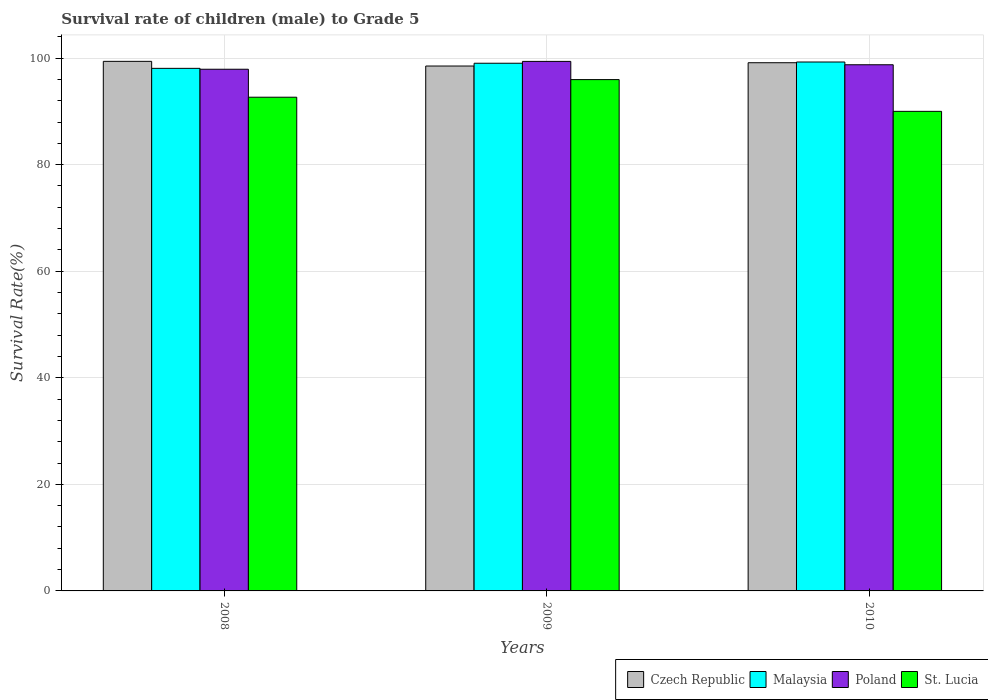How many different coloured bars are there?
Provide a short and direct response. 4. How many groups of bars are there?
Provide a short and direct response. 3. Are the number of bars per tick equal to the number of legend labels?
Your response must be concise. Yes. What is the survival rate of male children to grade 5 in Czech Republic in 2010?
Make the answer very short. 99.13. Across all years, what is the maximum survival rate of male children to grade 5 in Malaysia?
Your response must be concise. 99.26. Across all years, what is the minimum survival rate of male children to grade 5 in Czech Republic?
Ensure brevity in your answer.  98.51. In which year was the survival rate of male children to grade 5 in St. Lucia minimum?
Your answer should be compact. 2010. What is the total survival rate of male children to grade 5 in St. Lucia in the graph?
Make the answer very short. 278.62. What is the difference between the survival rate of male children to grade 5 in Czech Republic in 2008 and that in 2010?
Your response must be concise. 0.26. What is the difference between the survival rate of male children to grade 5 in Poland in 2008 and the survival rate of male children to grade 5 in Malaysia in 2010?
Provide a short and direct response. -1.36. What is the average survival rate of male children to grade 5 in Poland per year?
Your response must be concise. 98.67. In the year 2009, what is the difference between the survival rate of male children to grade 5 in Czech Republic and survival rate of male children to grade 5 in Malaysia?
Make the answer very short. -0.52. In how many years, is the survival rate of male children to grade 5 in Czech Republic greater than 64 %?
Your response must be concise. 3. What is the ratio of the survival rate of male children to grade 5 in Czech Republic in 2008 to that in 2009?
Keep it short and to the point. 1.01. Is the difference between the survival rate of male children to grade 5 in Czech Republic in 2008 and 2009 greater than the difference between the survival rate of male children to grade 5 in Malaysia in 2008 and 2009?
Your answer should be compact. Yes. What is the difference between the highest and the second highest survival rate of male children to grade 5 in Malaysia?
Keep it short and to the point. 0.23. What is the difference between the highest and the lowest survival rate of male children to grade 5 in Poland?
Ensure brevity in your answer.  1.47. In how many years, is the survival rate of male children to grade 5 in St. Lucia greater than the average survival rate of male children to grade 5 in St. Lucia taken over all years?
Your answer should be compact. 1. What does the 2nd bar from the left in 2010 represents?
Give a very brief answer. Malaysia. What does the 2nd bar from the right in 2010 represents?
Your response must be concise. Poland. How many bars are there?
Your answer should be compact. 12. How many years are there in the graph?
Ensure brevity in your answer.  3. Does the graph contain any zero values?
Your response must be concise. No. Where does the legend appear in the graph?
Your answer should be very brief. Bottom right. How are the legend labels stacked?
Make the answer very short. Horizontal. What is the title of the graph?
Give a very brief answer. Survival rate of children (male) to Grade 5. What is the label or title of the X-axis?
Your response must be concise. Years. What is the label or title of the Y-axis?
Provide a short and direct response. Survival Rate(%). What is the Survival Rate(%) in Czech Republic in 2008?
Make the answer very short. 99.38. What is the Survival Rate(%) of Malaysia in 2008?
Make the answer very short. 98.07. What is the Survival Rate(%) in Poland in 2008?
Offer a terse response. 97.9. What is the Survival Rate(%) of St. Lucia in 2008?
Your answer should be compact. 92.65. What is the Survival Rate(%) in Czech Republic in 2009?
Provide a short and direct response. 98.51. What is the Survival Rate(%) in Malaysia in 2009?
Offer a very short reply. 99.03. What is the Survival Rate(%) of Poland in 2009?
Provide a succinct answer. 99.38. What is the Survival Rate(%) in St. Lucia in 2009?
Keep it short and to the point. 95.96. What is the Survival Rate(%) of Czech Republic in 2010?
Offer a very short reply. 99.13. What is the Survival Rate(%) of Malaysia in 2010?
Offer a very short reply. 99.26. What is the Survival Rate(%) of Poland in 2010?
Give a very brief answer. 98.74. What is the Survival Rate(%) in St. Lucia in 2010?
Ensure brevity in your answer.  90. Across all years, what is the maximum Survival Rate(%) in Czech Republic?
Your answer should be compact. 99.38. Across all years, what is the maximum Survival Rate(%) of Malaysia?
Offer a very short reply. 99.26. Across all years, what is the maximum Survival Rate(%) of Poland?
Your answer should be very brief. 99.38. Across all years, what is the maximum Survival Rate(%) of St. Lucia?
Your response must be concise. 95.96. Across all years, what is the minimum Survival Rate(%) of Czech Republic?
Offer a very short reply. 98.51. Across all years, what is the minimum Survival Rate(%) of Malaysia?
Ensure brevity in your answer.  98.07. Across all years, what is the minimum Survival Rate(%) of Poland?
Make the answer very short. 97.9. Across all years, what is the minimum Survival Rate(%) in St. Lucia?
Give a very brief answer. 90. What is the total Survival Rate(%) of Czech Republic in the graph?
Give a very brief answer. 297.02. What is the total Survival Rate(%) of Malaysia in the graph?
Provide a short and direct response. 296.36. What is the total Survival Rate(%) in Poland in the graph?
Make the answer very short. 296.02. What is the total Survival Rate(%) in St. Lucia in the graph?
Keep it short and to the point. 278.62. What is the difference between the Survival Rate(%) in Czech Republic in 2008 and that in 2009?
Provide a succinct answer. 0.88. What is the difference between the Survival Rate(%) of Malaysia in 2008 and that in 2009?
Offer a very short reply. -0.96. What is the difference between the Survival Rate(%) of Poland in 2008 and that in 2009?
Your answer should be very brief. -1.47. What is the difference between the Survival Rate(%) in St. Lucia in 2008 and that in 2009?
Make the answer very short. -3.31. What is the difference between the Survival Rate(%) in Czech Republic in 2008 and that in 2010?
Keep it short and to the point. 0.26. What is the difference between the Survival Rate(%) of Malaysia in 2008 and that in 2010?
Offer a terse response. -1.19. What is the difference between the Survival Rate(%) of Poland in 2008 and that in 2010?
Make the answer very short. -0.84. What is the difference between the Survival Rate(%) of St. Lucia in 2008 and that in 2010?
Your answer should be compact. 2.65. What is the difference between the Survival Rate(%) of Czech Republic in 2009 and that in 2010?
Your answer should be very brief. -0.62. What is the difference between the Survival Rate(%) in Malaysia in 2009 and that in 2010?
Offer a terse response. -0.23. What is the difference between the Survival Rate(%) in Poland in 2009 and that in 2010?
Your answer should be compact. 0.63. What is the difference between the Survival Rate(%) in St. Lucia in 2009 and that in 2010?
Make the answer very short. 5.96. What is the difference between the Survival Rate(%) of Czech Republic in 2008 and the Survival Rate(%) of Malaysia in 2009?
Give a very brief answer. 0.36. What is the difference between the Survival Rate(%) in Czech Republic in 2008 and the Survival Rate(%) in Poland in 2009?
Ensure brevity in your answer.  0.01. What is the difference between the Survival Rate(%) in Czech Republic in 2008 and the Survival Rate(%) in St. Lucia in 2009?
Your answer should be very brief. 3.42. What is the difference between the Survival Rate(%) of Malaysia in 2008 and the Survival Rate(%) of Poland in 2009?
Keep it short and to the point. -1.31. What is the difference between the Survival Rate(%) in Malaysia in 2008 and the Survival Rate(%) in St. Lucia in 2009?
Your answer should be very brief. 2.11. What is the difference between the Survival Rate(%) in Poland in 2008 and the Survival Rate(%) in St. Lucia in 2009?
Provide a succinct answer. 1.94. What is the difference between the Survival Rate(%) of Czech Republic in 2008 and the Survival Rate(%) of Malaysia in 2010?
Keep it short and to the point. 0.12. What is the difference between the Survival Rate(%) of Czech Republic in 2008 and the Survival Rate(%) of Poland in 2010?
Offer a terse response. 0.64. What is the difference between the Survival Rate(%) in Czech Republic in 2008 and the Survival Rate(%) in St. Lucia in 2010?
Offer a very short reply. 9.38. What is the difference between the Survival Rate(%) of Malaysia in 2008 and the Survival Rate(%) of Poland in 2010?
Make the answer very short. -0.67. What is the difference between the Survival Rate(%) of Malaysia in 2008 and the Survival Rate(%) of St. Lucia in 2010?
Provide a short and direct response. 8.07. What is the difference between the Survival Rate(%) in Poland in 2008 and the Survival Rate(%) in St. Lucia in 2010?
Ensure brevity in your answer.  7.9. What is the difference between the Survival Rate(%) in Czech Republic in 2009 and the Survival Rate(%) in Malaysia in 2010?
Your answer should be compact. -0.75. What is the difference between the Survival Rate(%) of Czech Republic in 2009 and the Survival Rate(%) of Poland in 2010?
Make the answer very short. -0.24. What is the difference between the Survival Rate(%) in Czech Republic in 2009 and the Survival Rate(%) in St. Lucia in 2010?
Your answer should be compact. 8.51. What is the difference between the Survival Rate(%) of Malaysia in 2009 and the Survival Rate(%) of Poland in 2010?
Offer a terse response. 0.28. What is the difference between the Survival Rate(%) in Malaysia in 2009 and the Survival Rate(%) in St. Lucia in 2010?
Offer a terse response. 9.03. What is the difference between the Survival Rate(%) in Poland in 2009 and the Survival Rate(%) in St. Lucia in 2010?
Your answer should be compact. 9.38. What is the average Survival Rate(%) of Czech Republic per year?
Your answer should be very brief. 99.01. What is the average Survival Rate(%) in Malaysia per year?
Offer a very short reply. 98.79. What is the average Survival Rate(%) of Poland per year?
Ensure brevity in your answer.  98.67. What is the average Survival Rate(%) in St. Lucia per year?
Keep it short and to the point. 92.87. In the year 2008, what is the difference between the Survival Rate(%) in Czech Republic and Survival Rate(%) in Malaysia?
Offer a very short reply. 1.31. In the year 2008, what is the difference between the Survival Rate(%) in Czech Republic and Survival Rate(%) in Poland?
Offer a very short reply. 1.48. In the year 2008, what is the difference between the Survival Rate(%) in Czech Republic and Survival Rate(%) in St. Lucia?
Your answer should be compact. 6.73. In the year 2008, what is the difference between the Survival Rate(%) in Malaysia and Survival Rate(%) in Poland?
Offer a very short reply. 0.17. In the year 2008, what is the difference between the Survival Rate(%) of Malaysia and Survival Rate(%) of St. Lucia?
Ensure brevity in your answer.  5.42. In the year 2008, what is the difference between the Survival Rate(%) of Poland and Survival Rate(%) of St. Lucia?
Offer a terse response. 5.25. In the year 2009, what is the difference between the Survival Rate(%) in Czech Republic and Survival Rate(%) in Malaysia?
Your answer should be compact. -0.52. In the year 2009, what is the difference between the Survival Rate(%) of Czech Republic and Survival Rate(%) of Poland?
Offer a terse response. -0.87. In the year 2009, what is the difference between the Survival Rate(%) of Czech Republic and Survival Rate(%) of St. Lucia?
Offer a very short reply. 2.55. In the year 2009, what is the difference between the Survival Rate(%) in Malaysia and Survival Rate(%) in Poland?
Provide a succinct answer. -0.35. In the year 2009, what is the difference between the Survival Rate(%) of Malaysia and Survival Rate(%) of St. Lucia?
Give a very brief answer. 3.07. In the year 2009, what is the difference between the Survival Rate(%) in Poland and Survival Rate(%) in St. Lucia?
Provide a short and direct response. 3.42. In the year 2010, what is the difference between the Survival Rate(%) of Czech Republic and Survival Rate(%) of Malaysia?
Offer a very short reply. -0.14. In the year 2010, what is the difference between the Survival Rate(%) of Czech Republic and Survival Rate(%) of Poland?
Your answer should be very brief. 0.38. In the year 2010, what is the difference between the Survival Rate(%) of Czech Republic and Survival Rate(%) of St. Lucia?
Your response must be concise. 9.12. In the year 2010, what is the difference between the Survival Rate(%) of Malaysia and Survival Rate(%) of Poland?
Provide a short and direct response. 0.52. In the year 2010, what is the difference between the Survival Rate(%) of Malaysia and Survival Rate(%) of St. Lucia?
Provide a succinct answer. 9.26. In the year 2010, what is the difference between the Survival Rate(%) in Poland and Survival Rate(%) in St. Lucia?
Provide a succinct answer. 8.74. What is the ratio of the Survival Rate(%) of Czech Republic in 2008 to that in 2009?
Provide a short and direct response. 1.01. What is the ratio of the Survival Rate(%) in Malaysia in 2008 to that in 2009?
Make the answer very short. 0.99. What is the ratio of the Survival Rate(%) in Poland in 2008 to that in 2009?
Give a very brief answer. 0.99. What is the ratio of the Survival Rate(%) in St. Lucia in 2008 to that in 2009?
Provide a short and direct response. 0.97. What is the ratio of the Survival Rate(%) of Malaysia in 2008 to that in 2010?
Give a very brief answer. 0.99. What is the ratio of the Survival Rate(%) of Poland in 2008 to that in 2010?
Keep it short and to the point. 0.99. What is the ratio of the Survival Rate(%) of St. Lucia in 2008 to that in 2010?
Your answer should be compact. 1.03. What is the ratio of the Survival Rate(%) of Malaysia in 2009 to that in 2010?
Your answer should be compact. 1. What is the ratio of the Survival Rate(%) of Poland in 2009 to that in 2010?
Make the answer very short. 1.01. What is the ratio of the Survival Rate(%) in St. Lucia in 2009 to that in 2010?
Make the answer very short. 1.07. What is the difference between the highest and the second highest Survival Rate(%) in Czech Republic?
Provide a short and direct response. 0.26. What is the difference between the highest and the second highest Survival Rate(%) in Malaysia?
Provide a succinct answer. 0.23. What is the difference between the highest and the second highest Survival Rate(%) in Poland?
Ensure brevity in your answer.  0.63. What is the difference between the highest and the second highest Survival Rate(%) of St. Lucia?
Your response must be concise. 3.31. What is the difference between the highest and the lowest Survival Rate(%) in Czech Republic?
Make the answer very short. 0.88. What is the difference between the highest and the lowest Survival Rate(%) in Malaysia?
Give a very brief answer. 1.19. What is the difference between the highest and the lowest Survival Rate(%) in Poland?
Ensure brevity in your answer.  1.47. What is the difference between the highest and the lowest Survival Rate(%) of St. Lucia?
Offer a very short reply. 5.96. 